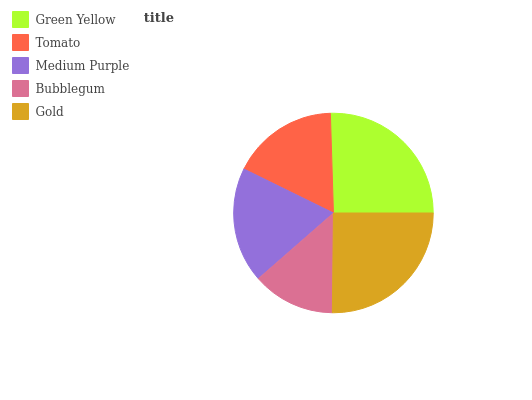Is Bubblegum the minimum?
Answer yes or no. Yes. Is Green Yellow the maximum?
Answer yes or no. Yes. Is Tomato the minimum?
Answer yes or no. No. Is Tomato the maximum?
Answer yes or no. No. Is Green Yellow greater than Tomato?
Answer yes or no. Yes. Is Tomato less than Green Yellow?
Answer yes or no. Yes. Is Tomato greater than Green Yellow?
Answer yes or no. No. Is Green Yellow less than Tomato?
Answer yes or no. No. Is Medium Purple the high median?
Answer yes or no. Yes. Is Medium Purple the low median?
Answer yes or no. Yes. Is Green Yellow the high median?
Answer yes or no. No. Is Tomato the low median?
Answer yes or no. No. 